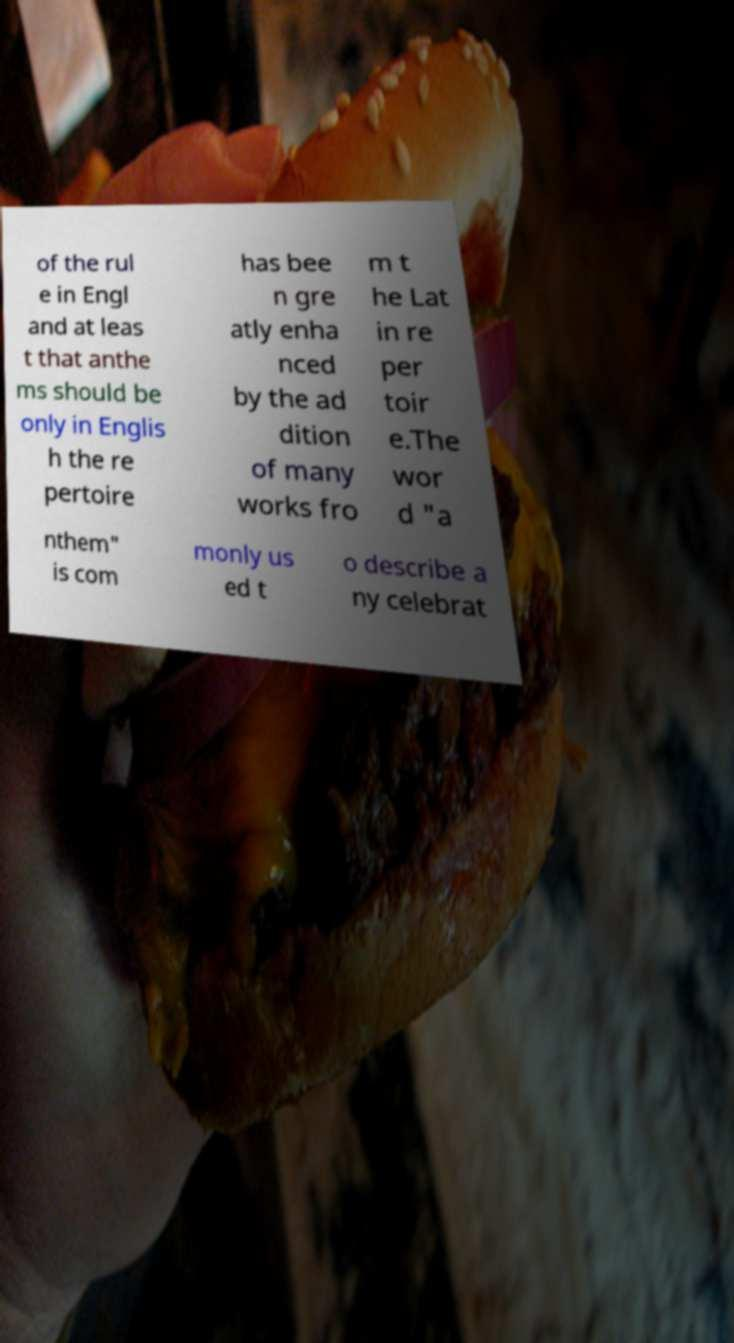Could you assist in decoding the text presented in this image and type it out clearly? of the rul e in Engl and at leas t that anthe ms should be only in Englis h the re pertoire has bee n gre atly enha nced by the ad dition of many works fro m t he Lat in re per toir e.The wor d "a nthem" is com monly us ed t o describe a ny celebrat 